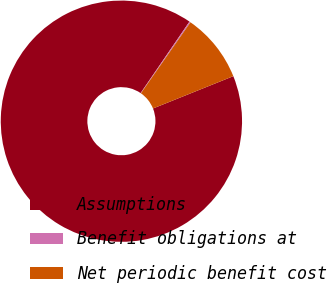Convert chart. <chart><loc_0><loc_0><loc_500><loc_500><pie_chart><fcel>Assumptions<fcel>Benefit obligations at<fcel>Net periodic benefit cost<nl><fcel>90.64%<fcel>0.16%<fcel>9.21%<nl></chart> 